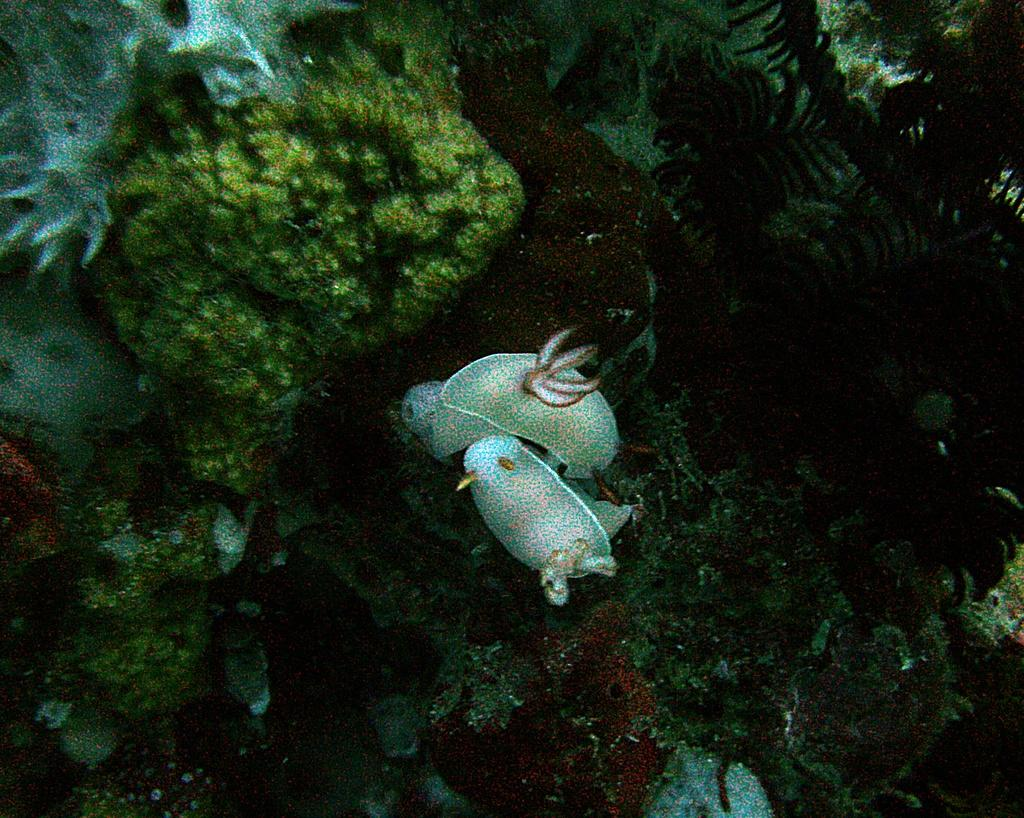What type of plants can be seen in the image? There are underwater plants in the image. What else can be seen in the image besides the plants? There are rock stones and fishes present in the image. What type of business is being conducted in the image? There is no indication of any business being conducted in the image; it features underwater plants, rock stones, and fishes. 